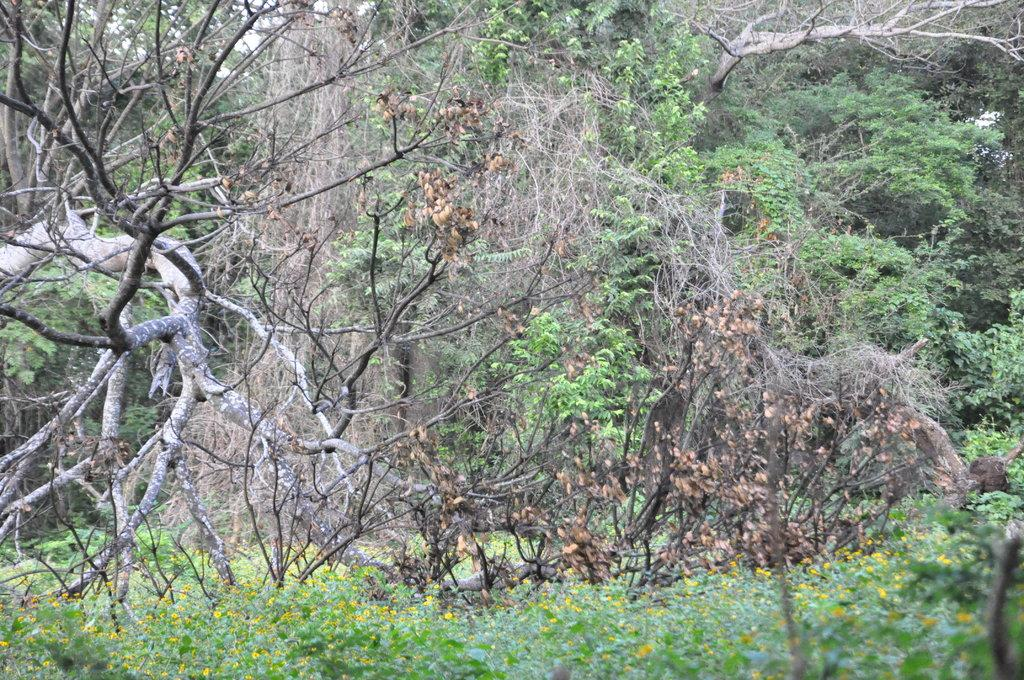What type of vegetation can be seen in the image? There are trees and plants with flowers in the image. Can you describe the plants with flowers in the image? The plants with flowers are not specified in detail, but they are present in the image. What type of electrical system is visible in the image? There is no electrical system present in the image; it features trees and plants with flowers. Can you describe the beggar sitting near the plants in the image? There is no beggar present in the image; it only features trees and plants with flowers. 